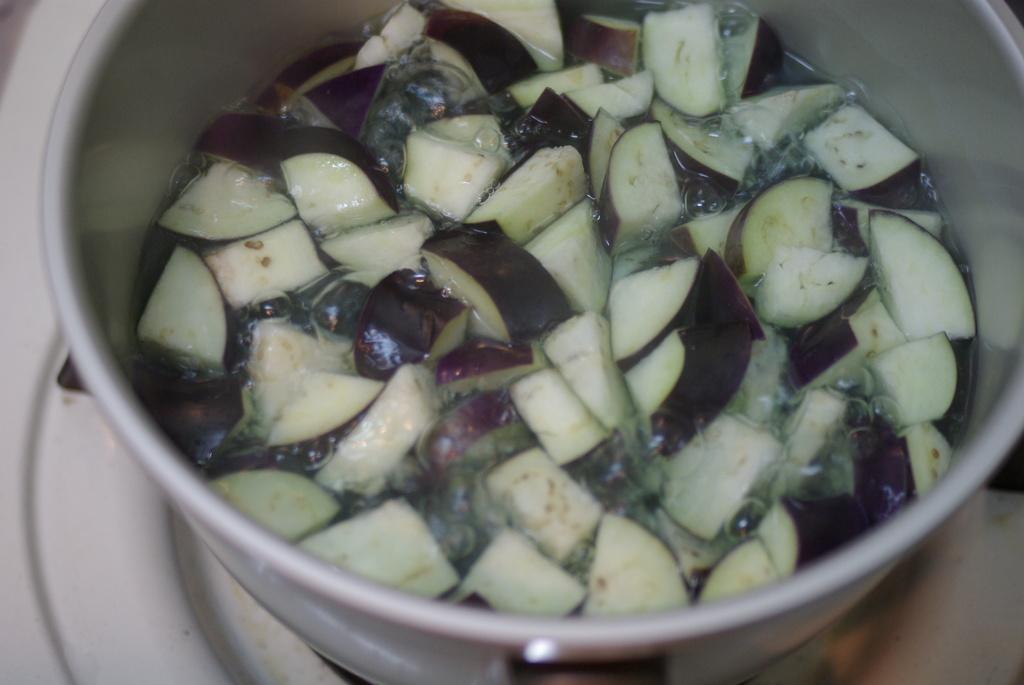What is in the bowl that is visible in the image? The bowl contains water and pieces of vegetables. What is the bowl placed on in the image? The bowl is placed on a surface. What type of furniture is present in the image? There is no furniture present in the image; it only features a bowl with water and vegetables on a surface. 